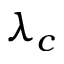Convert formula to latex. <formula><loc_0><loc_0><loc_500><loc_500>\lambda _ { c }</formula> 